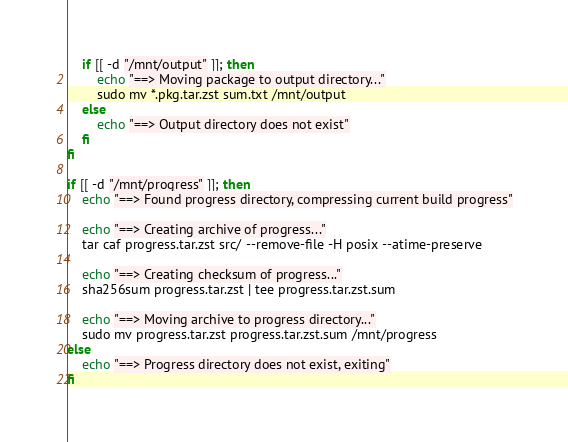Convert code to text. <code><loc_0><loc_0><loc_500><loc_500><_Bash_>    if [[ -d "/mnt/output" ]]; then
        echo "==> Moving package to output directory..."
        sudo mv *.pkg.tar.zst sum.txt /mnt/output
    else
        echo "==> Output directory does not exist"
    fi
fi

if [[ -d "/mnt/progress" ]]; then
    echo "==> Found progress directory, compressing current build progress"

    echo "==> Creating archive of progress..."
    tar caf progress.tar.zst src/ --remove-file -H posix --atime-preserve

    echo "==> Creating checksum of progress..."
    sha256sum progress.tar.zst | tee progress.tar.zst.sum

    echo "==> Moving archive to progress directory..."
    sudo mv progress.tar.zst progress.tar.zst.sum /mnt/progress
else
    echo "==> Progress directory does not exist, exiting"
fi
</code> 